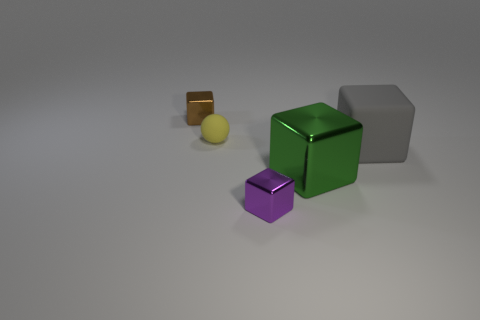How would you describe the colors in the scene? The scene presents a muted palette with the objects themselves being the main sources of color. We have a green cube with a vibrant, almost reflective hue, contrasting with the more subdued, matte purple of the smaller cube. The brown of the smallest cube is subtle and earthy, while the gray object has a neutral tone that blends with the background. The small yellow sphere adds a dash of bright, lemony color to the mix. 